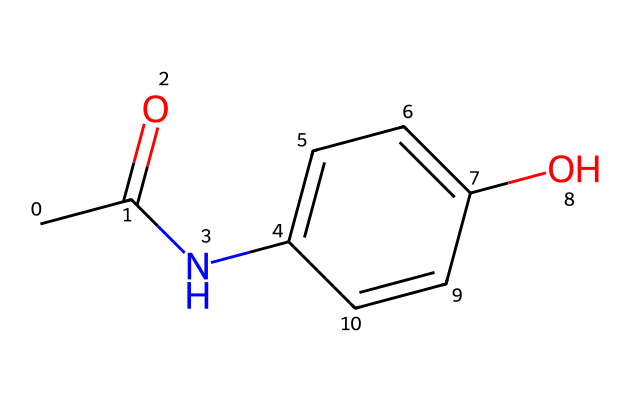What is the molecular formula of this chemical? To find the molecular formula, we count the atoms of each element in the structure. The chemical consists of 8 carbon (C), 9 hydrogen (H), 1 nitrogen (N), and 3 oxygen (O) atoms. Therefore, the molecular formula is C8H9NO3.
Answer: C8H9NO3 How many rings are present in the structure? By examining the structure, we note that there is one cyclic component in the chemical, which is a phenolic ring. Hence, there is one ring present.
Answer: one Is this compound classified as an analgesic? Acetaminophen is widely recognized as an analgesic, meaning it is used to relieve pain. The chemical structure indicates that it has properties characteristic of analgesics.
Answer: yes What type of drug is this compound? Acetaminophen is classified as a non-opioid analgesic and antipyretic based on its therapeutic use and chemical properties. Consequently, it falls under these specific drug classifications.
Answer: analgesic and antipyretic How does this drug primarily exert its effects in the body? Acetaminophen primarily works by inhibiting cyclooxygenase enzymes in the brain and reducing prostaglandin synthesis, which explains its mechanism of action in providing pain relief and lowering fever.
Answer: inhibits cyclooxygenase What is the half-life of acetaminophen in pediatric patients? The half-life of acetaminophen in pediatric patients typically ranges from 1 to 4 hours, depending on individual metabolic differences and other factors such as age and health status.
Answer: 1 to 4 hours What is the primary route of elimination for this drug? Acetaminophen is primarily metabolized in the liver and excreted through the kidneys. The elimination is largely done via the urine, where it is present as metabolites.
Answer: urine 